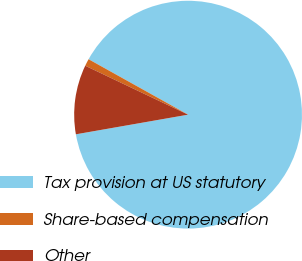Convert chart to OTSL. <chart><loc_0><loc_0><loc_500><loc_500><pie_chart><fcel>Tax provision at US statutory<fcel>Share-based compensation<fcel>Other<nl><fcel>89.15%<fcel>1.02%<fcel>9.83%<nl></chart> 